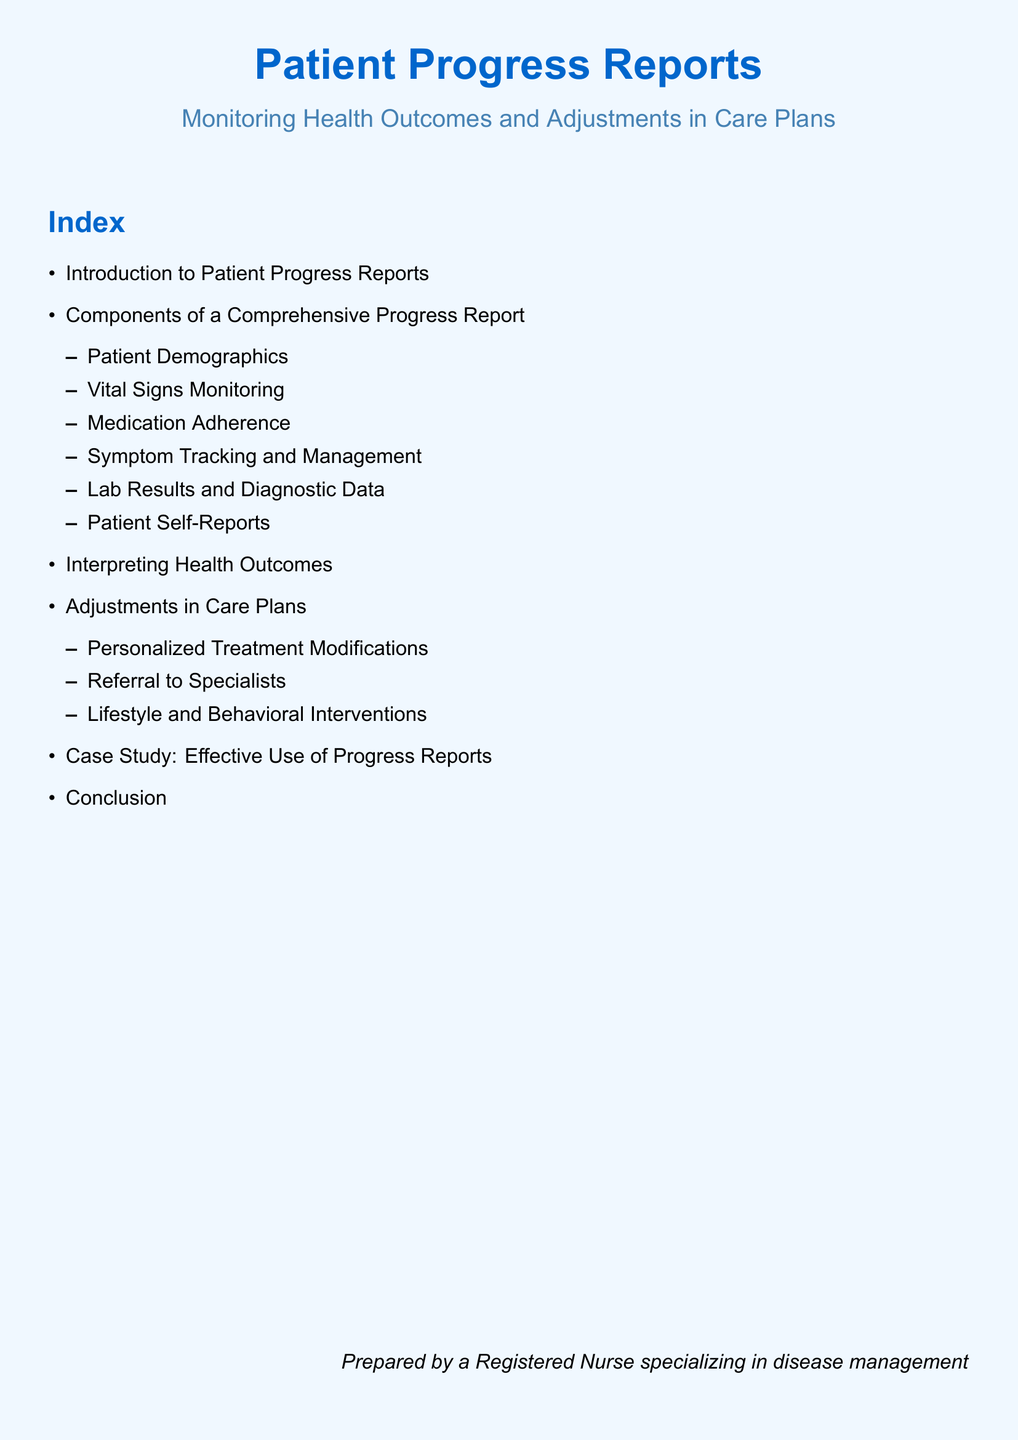what is the title of the document? The title is prominently displayed at the top of the document.
Answer: Patient Progress Reports how many components are listed in a comprehensive progress report? The index indicates a total number of sub-components listed under the comprehensive progress report section.
Answer: 6 what is the first component of a comprehensive progress report? The first item listed under the components section provides specific details.
Answer: Patient Demographics what type of modifications are included under adjustments in care plans? Referring to the subcategories listed in the index, this specifies the nature of adjustments discussed.
Answer: Personalized Treatment Modifications what is the primary purpose of the document? The introductory section outlines the main focus of the document related to patient care.
Answer: Monitoring Health Outcomes and Adjustments in Care Plans what case is mentioned in the index? The index indicates the specific example provided in the document, which shows application of concepts discussed.
Answer: Case Study: Effective Use of Progress Reports how many main sections are there in the index? By counting the main items listed in the index, we can identify the structure of the document.
Answer: 6 